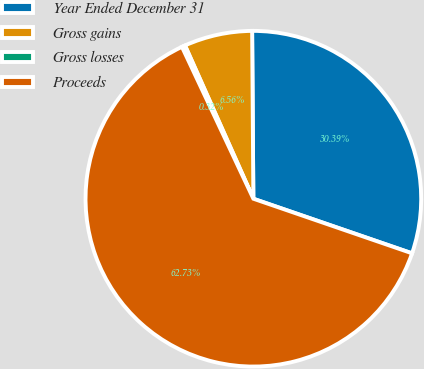<chart> <loc_0><loc_0><loc_500><loc_500><pie_chart><fcel>Year Ended December 31<fcel>Gross gains<fcel>Gross losses<fcel>Proceeds<nl><fcel>30.39%<fcel>6.56%<fcel>0.32%<fcel>62.73%<nl></chart> 